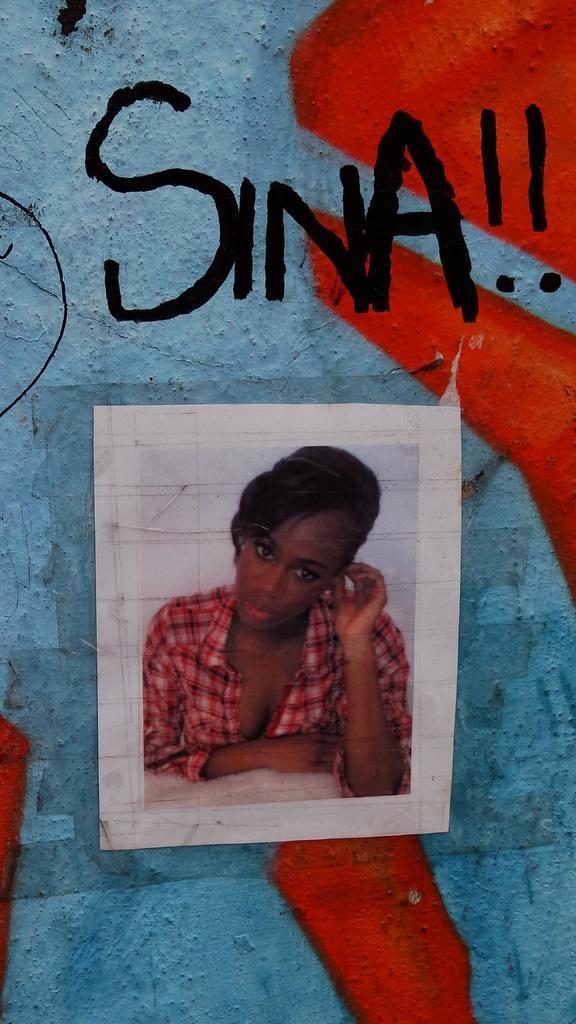Can you describe this image briefly? In the image there is a photo of a lady in red shirt on a paper on the wall. 